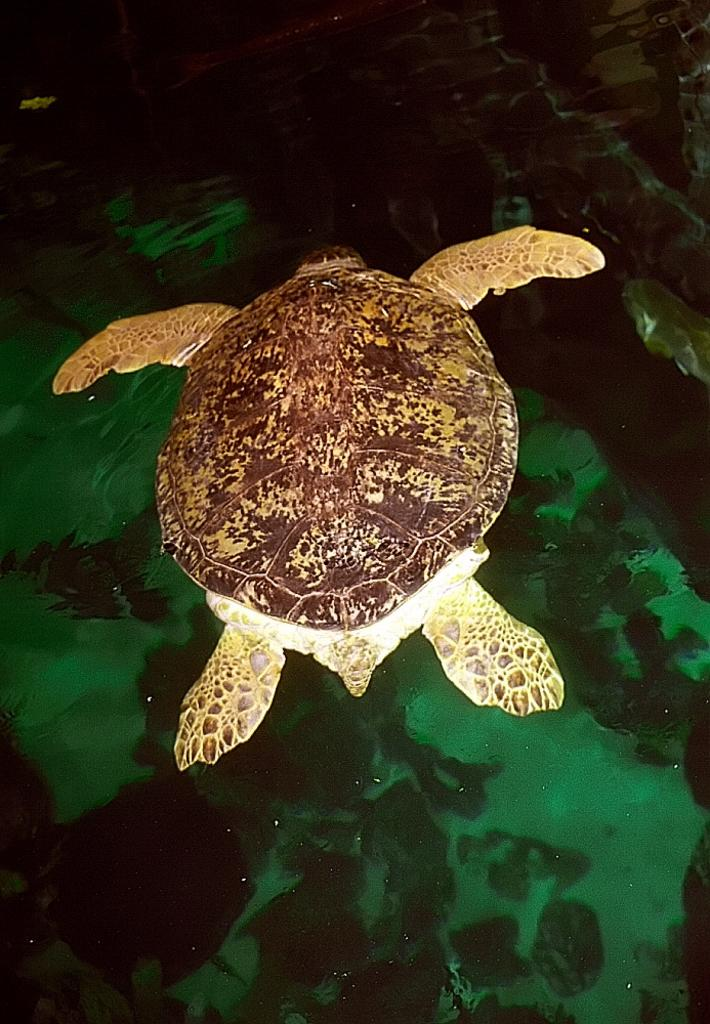What type of animal is in the image? There is a tortoise in the image. What is the tortoise situated near or on in the image? There is water below the tortoise in the image. What type of produce is being harvested by the tortoise in the image? There is no produce or harvesting activity depicted in the image; it features a tortoise near water. Can you see an airplane in the image? No, there is no airplane present in the image. 